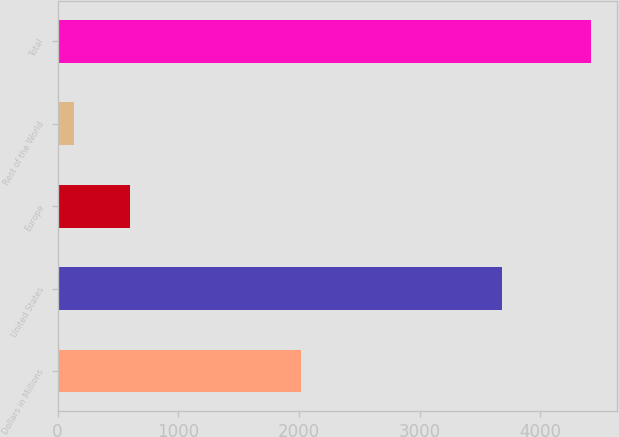Convert chart. <chart><loc_0><loc_0><loc_500><loc_500><bar_chart><fcel>Dollars in Millions<fcel>United States<fcel>Europe<fcel>Rest of the World<fcel>Total<nl><fcel>2014<fcel>3686<fcel>597<fcel>134<fcel>4417<nl></chart> 